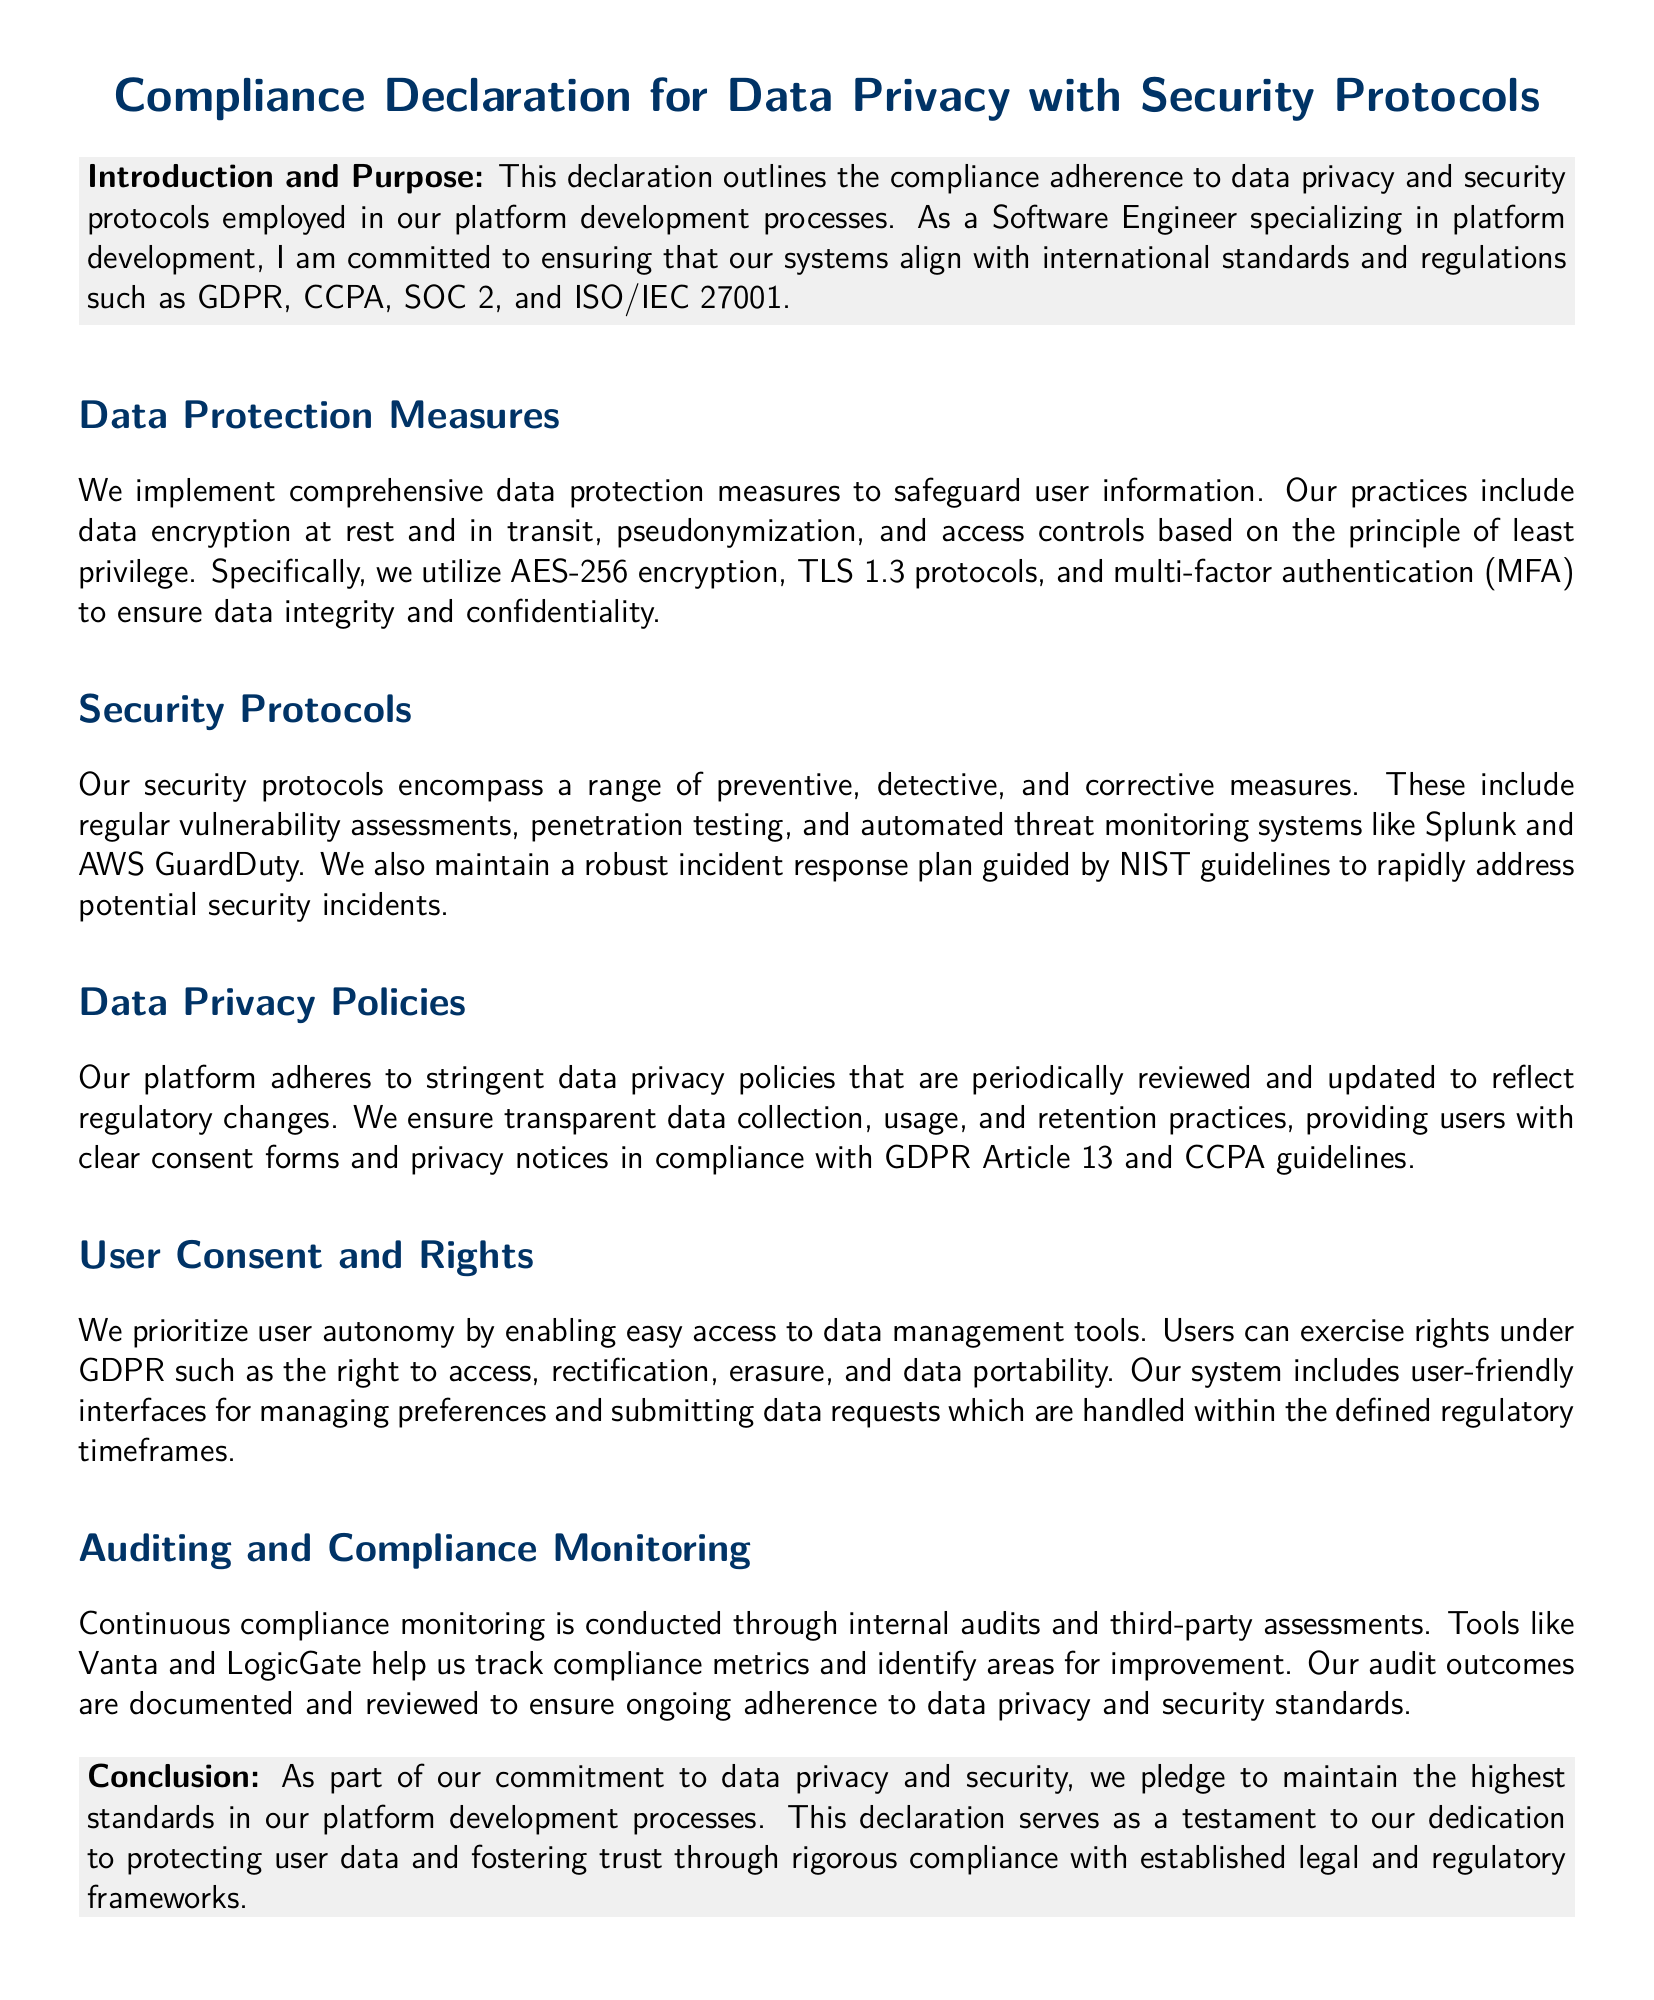What is the title of the declaration? The title summarizes the subject of the document, specifically focusing on compliance and data privacy.
Answer: Compliance Declaration for Data Privacy with Security Protocols What encryption method is used for data at rest? This detail highlights specific security measures in the document's data protection section.
Answer: AES-256 encryption What protocols are mentioned for data transmission security? The document states specific methods for protecting data as it is transmitted.
Answer: TLS 1.3 protocols Which guidelines guide the incident response plan? The reference to external guidelines shows the framework for the response processes.
Answer: NIST guidelines What rights can users exercise under GDPR? This question addresses the rights mentioned related to user data management in the privacy section.
Answer: access, rectification, erasure, data portability What tools help track compliance metrics? This highlights the specific tools utilized for compliance monitoring as noted in the document.
Answer: Vanta and LogicGate How often are data privacy policies updated? This requires reasoning about the organization's commitment to keeping policies aligned with regulatory changes.
Answer: periodically What compliance standards are mentioned? This question summarizes the key standards referred to in the introduction for context.
Answer: GDPR, CCPA, SOC 2, and ISO/IEC 27001 